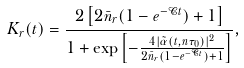Convert formula to latex. <formula><loc_0><loc_0><loc_500><loc_500>K _ { r } ( t ) = \frac { 2 \left [ 2 \bar { n } _ { r } ( 1 - e ^ { - \mathcal { C } t } ) + 1 \right ] } { 1 + \exp \left [ - \frac { 4 | \tilde { \alpha } ( t , n \tau _ { 0 } ) | ^ { 2 } } { 2 \bar { n } _ { r } ( 1 - e ^ { - \mathcal { C } t } ) + 1 } \right ] } ,</formula> 